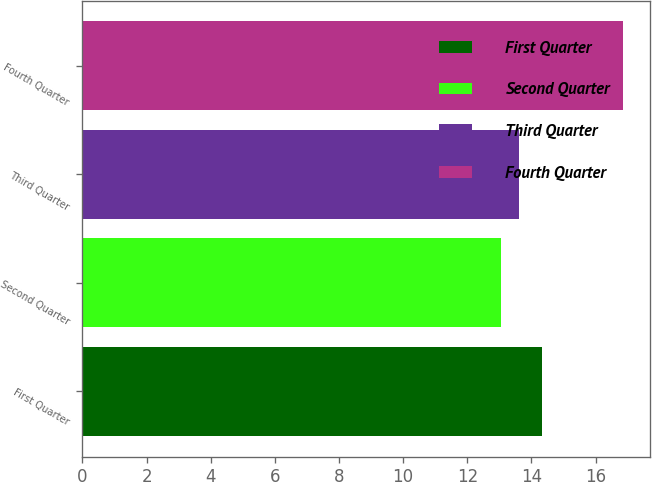Convert chart. <chart><loc_0><loc_0><loc_500><loc_500><bar_chart><fcel>First Quarter<fcel>Second Quarter<fcel>Third Quarter<fcel>Fourth Quarter<nl><fcel>14.34<fcel>13.05<fcel>13.6<fcel>16.85<nl></chart> 